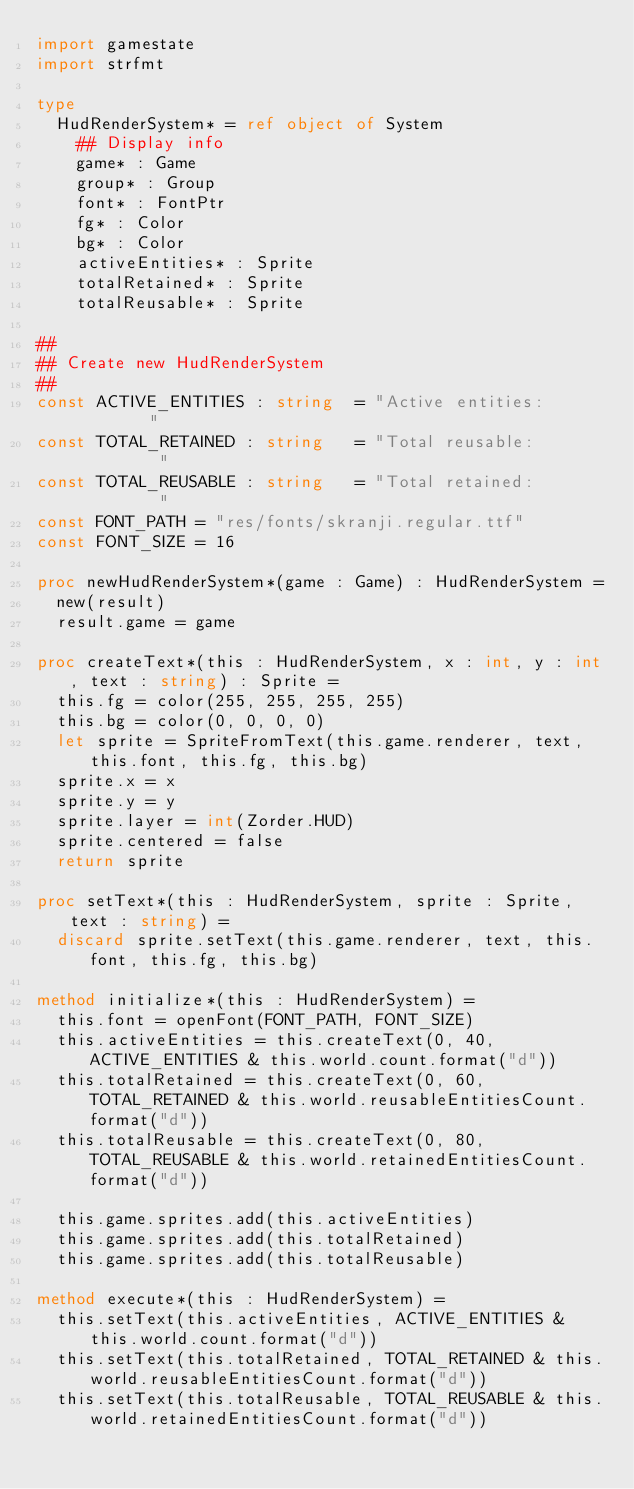Convert code to text. <code><loc_0><loc_0><loc_500><loc_500><_Nim_>import gamestate
import strfmt

type
  HudRenderSystem* = ref object of System
    ## Display info
    game* : Game
    group* : Group
    font* : FontPtr
    fg* : Color
    bg* : Color
    activeEntities* : Sprite
    totalRetained* : Sprite
    totalReusable* : Sprite

##
## Create new HudRenderSystem
##
const ACTIVE_ENTITIES : string  = "Active entities:         "
const TOTAL_RETAINED : string   = "Total reusable:          "
const TOTAL_REUSABLE : string   = "Total retained:          "
const FONT_PATH = "res/fonts/skranji.regular.ttf"
const FONT_SIZE = 16

proc newHudRenderSystem*(game : Game) : HudRenderSystem =
  new(result)
  result.game = game

proc createText*(this : HudRenderSystem, x : int, y : int, text : string) : Sprite =
  this.fg = color(255, 255, 255, 255)
  this.bg = color(0, 0, 0, 0)
  let sprite = SpriteFromText(this.game.renderer, text, this.font, this.fg, this.bg)
  sprite.x = x
  sprite.y = y
  sprite.layer = int(Zorder.HUD)
  sprite.centered = false
  return sprite

proc setText*(this : HudRenderSystem, sprite : Sprite, text : string) =
  discard sprite.setText(this.game.renderer, text, this.font, this.fg, this.bg)

method initialize*(this : HudRenderSystem) =
  this.font = openFont(FONT_PATH, FONT_SIZE)
  this.activeEntities = this.createText(0, 40, ACTIVE_ENTITIES & this.world.count.format("d"))
  this.totalRetained = this.createText(0, 60, TOTAL_RETAINED & this.world.reusableEntitiesCount.format("d"))
  this.totalReusable = this.createText(0, 80, TOTAL_REUSABLE & this.world.retainedEntitiesCount.format("d"))

  this.game.sprites.add(this.activeEntities)
  this.game.sprites.add(this.totalRetained)
  this.game.sprites.add(this.totalReusable)

method execute*(this : HudRenderSystem) =
  this.setText(this.activeEntities, ACTIVE_ENTITIES & this.world.count.format("d"))
  this.setText(this.totalRetained, TOTAL_RETAINED & this.world.reusableEntitiesCount.format("d"))
  this.setText(this.totalReusable, TOTAL_REUSABLE & this.world.retainedEntitiesCount.format("d"))

</code> 